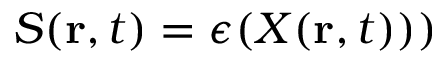<formula> <loc_0><loc_0><loc_500><loc_500>S ( r , t ) = \epsilon ( X ( r , t ) ) )</formula> 